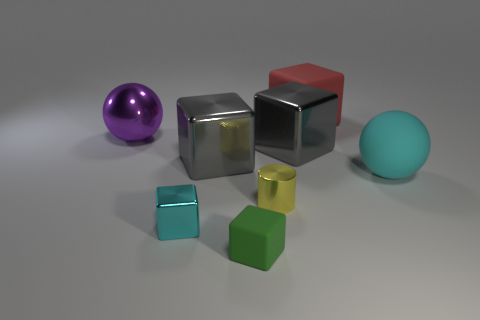There is a large thing that is the same color as the tiny shiny block; what is its shape?
Give a very brief answer. Sphere. What is the color of the other rubber object that is the same shape as the big purple object?
Your answer should be very brief. Cyan. Is the number of cylinders that are in front of the red block less than the number of tiny rubber things?
Provide a succinct answer. No. Are there any other things that have the same size as the cyan shiny cube?
Provide a short and direct response. Yes. There is a rubber cube in front of the cyan block in front of the red matte block; what is its size?
Your answer should be compact. Small. Is there any other thing that is the same shape as the purple object?
Your response must be concise. Yes. Are there fewer tiny gray things than big gray objects?
Your answer should be very brief. Yes. The large block that is on the right side of the small green thing and on the left side of the big red block is made of what material?
Make the answer very short. Metal. Are there any big gray metal objects in front of the matte block on the left side of the large red rubber thing?
Offer a terse response. No. What number of objects are either small cyan metallic cubes or tiny gray matte objects?
Your answer should be very brief. 1. 